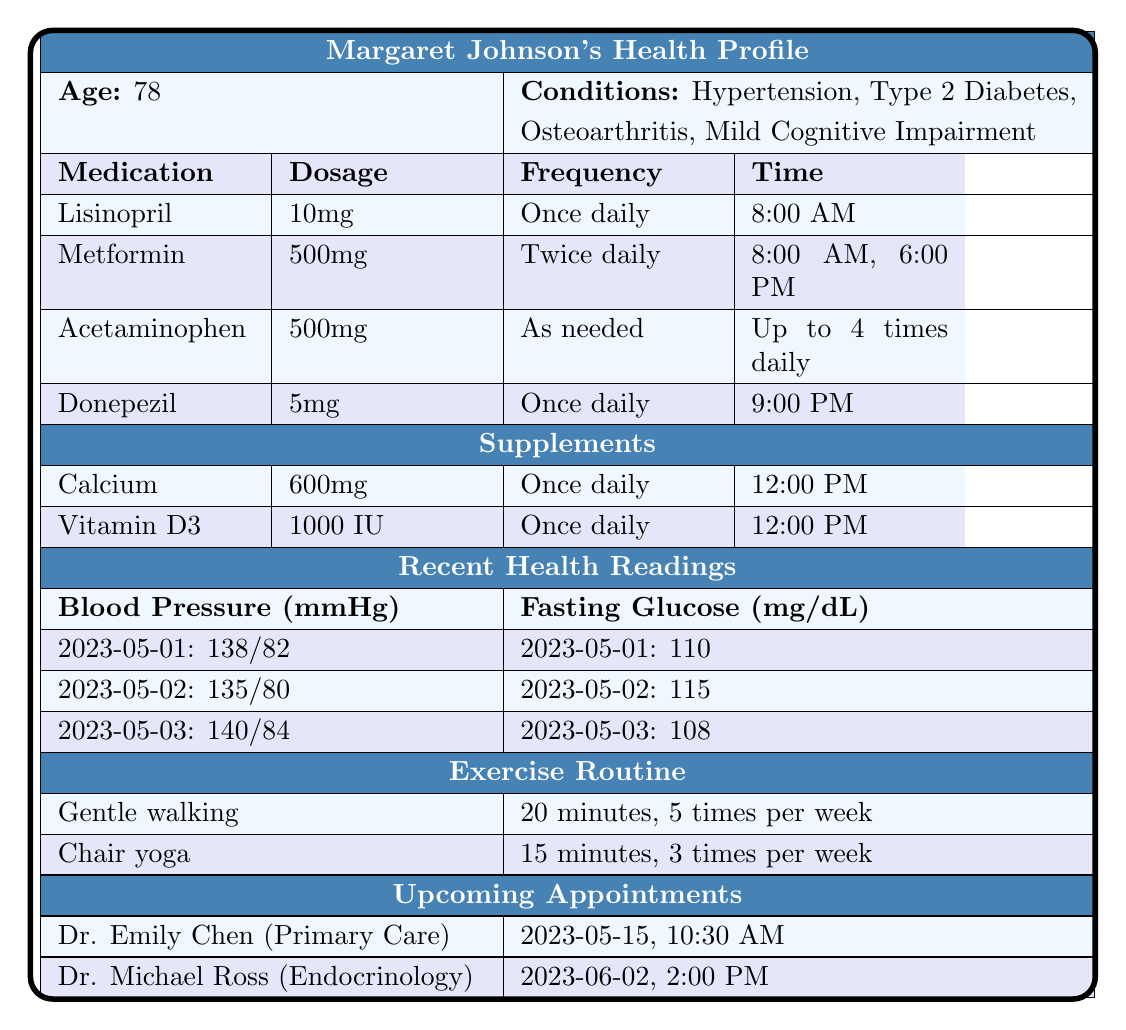What is the dosage for Lisinopril? The table lists Lisinopril under the medication section, where the dosage is specified as 10mg.
Answer: 10mg How many times a day does Margaret take Metformin? According to the table, Metformin is taken twice daily, as indicated under the frequency column.
Answer: Twice daily What time does Margaret take Donepezil? The medication Donepezil is listed with a time of 9:00 PM for administration in the table.
Answer: 9:00 PM Is Acetaminophen administered on a fixed schedule? The table indicates that Acetaminophen is taken as needed, meaning it does not follow a fixed schedule.
Answer: No How many total medications does Margaret take? The table shows a total of four medications listed under the medication section, which are Lisinopril, Metformin, Acetaminophen, and Donepezil.
Answer: Four What are the blood pressure readings for May 1, 2023? The blood pressure readings for May 1, 2023, show a systolic of 138 and a diastolic of 82, as indicated in the blood pressure readings section of the table.
Answer: 138/82 What is the average fasting glucose over the recorded days? The fasting glucose readings are 110, 115, and 108 for May 1, 2, and 3 respectively. The sum is 110 + 115 + 108 = 333, and the average is 333/3 = 111.
Answer: 111 How many different types of exercise does Margaret engage in? The exercise routine section lists two types of activities: gentle walking and chair yoga.
Answer: Two What is the duration of the chair yoga sessions? In the exercise routine, chair yoga is listed with a duration of 15 minutes per session.
Answer: 15 minutes Does Margaret have an upcoming appointment with a cardiologist? The upcoming appointments section lists Dr. Emily Chen and Dr. Michael Ross, and neither of them is a cardiologist. Therefore, Margaret does not have an upcoming appointment with a cardiologist.
Answer: No What is the combined dosage of Calcium and Vitamin D3 taken daily? Calcium (600mg) and Vitamin D3 (1000 IU) are both taken once daily. Therefore, the combined daily dosage is 600mg of Calcium and 1000 IU of Vitamin D3.
Answer: 600mg Calcium and 1000 IU Vitamin D3 What was the highest fasting glucose measurement recorded? Looking at the fasting glucose readings, 115 is the highest value recorded on May 2, 2023.
Answer: 115 How often does Margaret practice chair yoga compared to gentle walking? The table indicates that gentle walking is done 5 times per week and chair yoga is practiced 3 times per week, which shows that gentle walking is done more frequently than chair yoga.
Answer: More often What are the blood pressure readings for May 2, 2023? The blood pressure readings for May 2, 2023, show a systolic of 135 and a diastolic of 80, as mentioned in the blood pressure section.
Answer: 135/80 